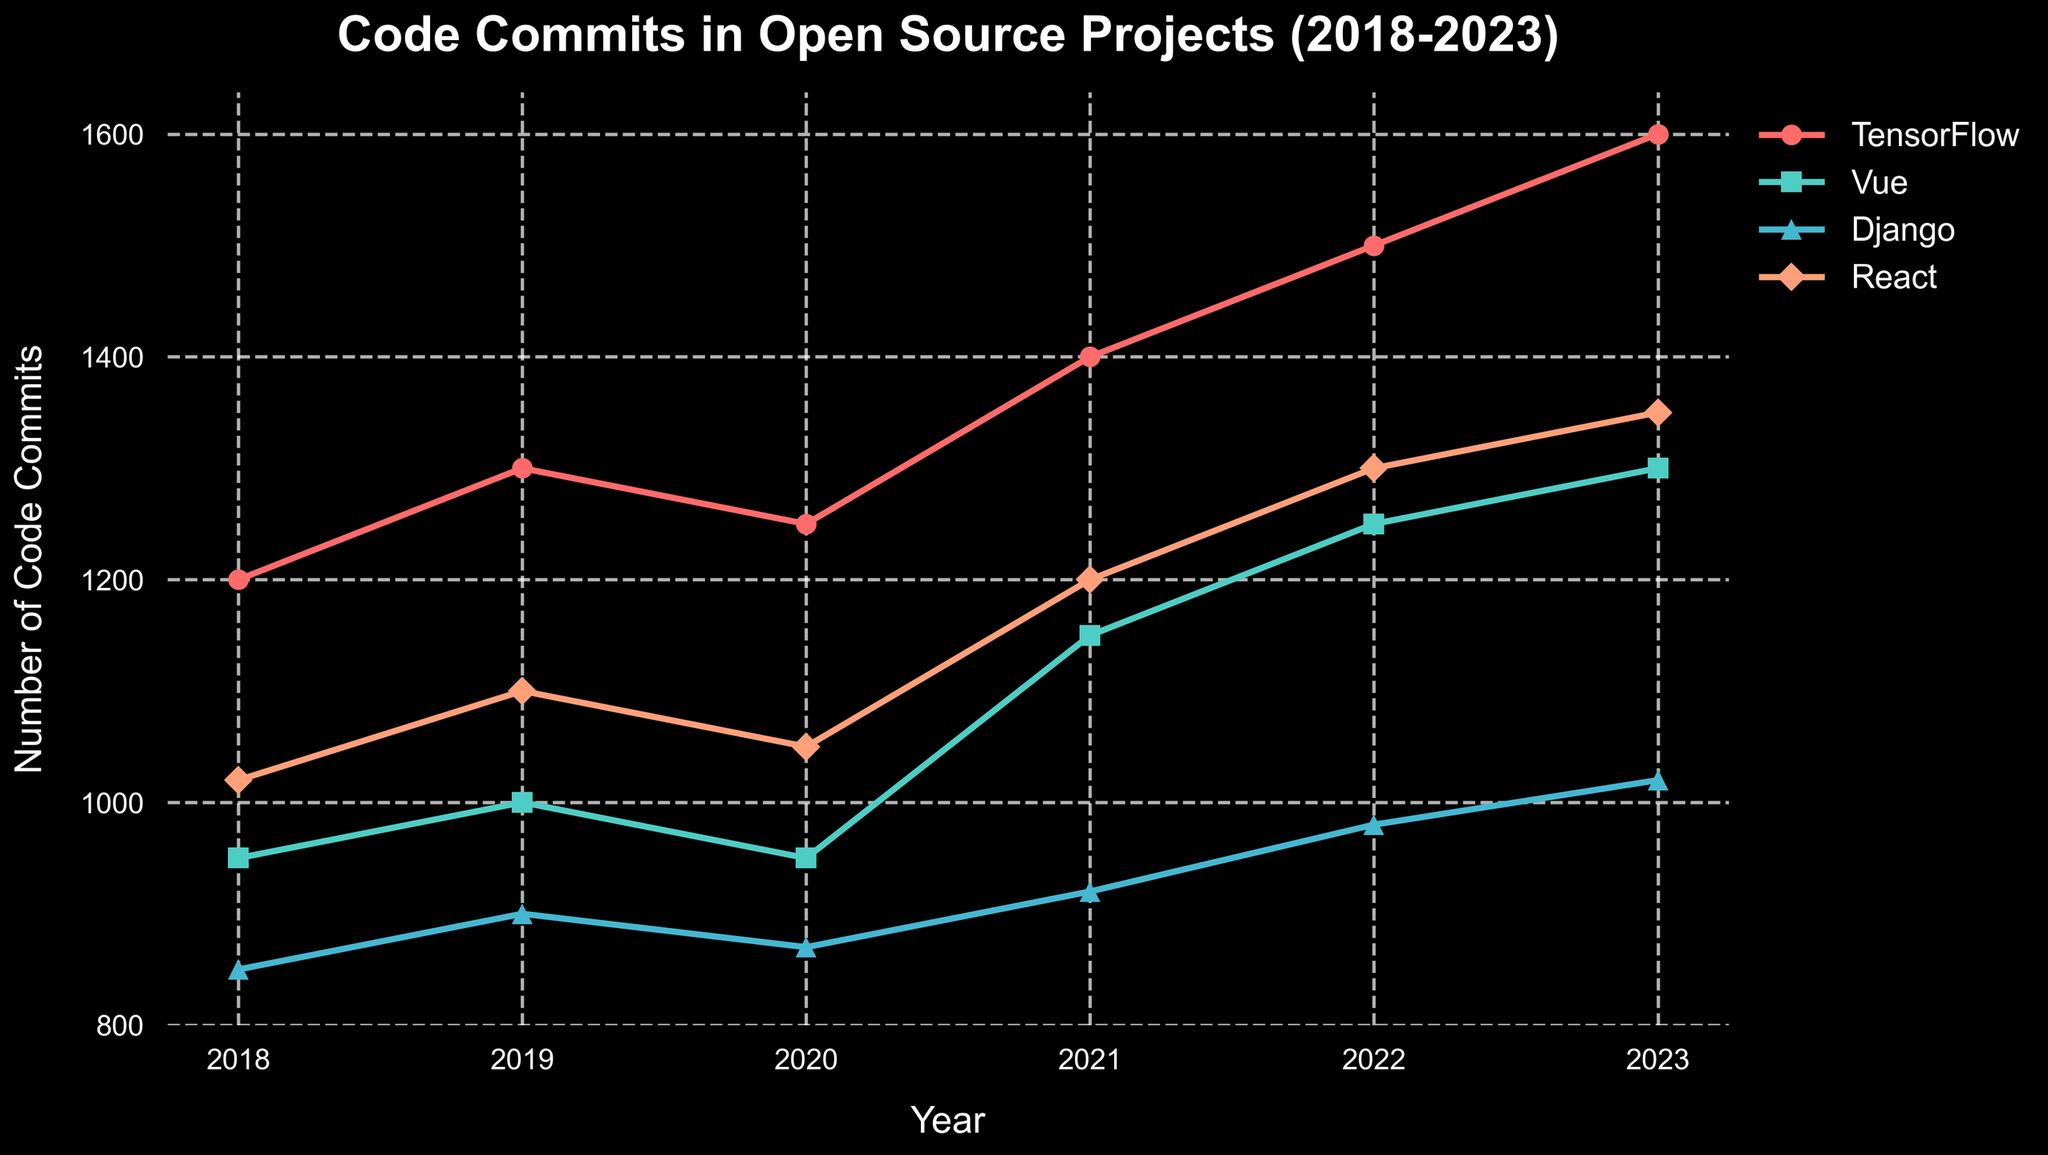What is the title of the plot? The title is located at the top of the plot and typically describes the main content or purpose of the figure. In this case, it reads "Code Commits in Open Source Projects (2018-2023)".
Answer: Code Commits in Open Source Projects (2018-2023) What is the trend for TensorFlow code commits from 2018 to 2023? To determine this, look at the year-by-year data points for TensorFlow. The number of code commits rises consistently from 1200 in 2018 to 1600 in 2023.
Answer: Increasing Which project had the highest number of code commits in 2022? Compare the peaks of the lines for each project in 2022. The highest value corresponds to TensorFlow, which has 1500 commits.
Answer: TensorFlow In which year did Vue see the maximum increase in code commits compared to the previous year? Calculate the difference in commits year-by-year for Vue. The increase between 2020 and 2021 is 200 (1150 - 950), the highest among the years.
Answer: 2021 How many total code commits did Django have from 2018 to 2023? Sum the number of code commits for each year for Django: \( 850 + 900 + 870 + 920 + 980 + 1020 = 5540 \).
Answer: 5540 Which project had the least number of code commits in 2019? Compare the 2019 values for all projects: TensorFlow (1300), Vue (1000), Django (900), and React (1100). Django has the lowest value with 900 commits.
Answer: Django Did any project experience a decrease in code commits from 2022 to 2023? Check each project's data from 2022 and 2023. All projects (TensorFlow, Vue, Django, React) show an increase or remain the same between these years.
Answer: No By how much did React's code commits increase from 2018 to 2023? Subtract React's 2018 commits (1020) from its 2023 commits (1350): \( 1350 - 1020 = 330 \).
Answer: 330 Which project had the most stable (least fluctuating) trend in code commits over the years? The project with the least difference between its highest and lowest values over the years is Vue (highest: 1300, lowest: 950).
Answer: Vue How does the number of code commits in 2020 for Django compare to Vue? Compare the values for Django and Vue in 2020: Django (870) and Vue (950). Vue has 80 more commits than Django.
Answer: Vue has more 